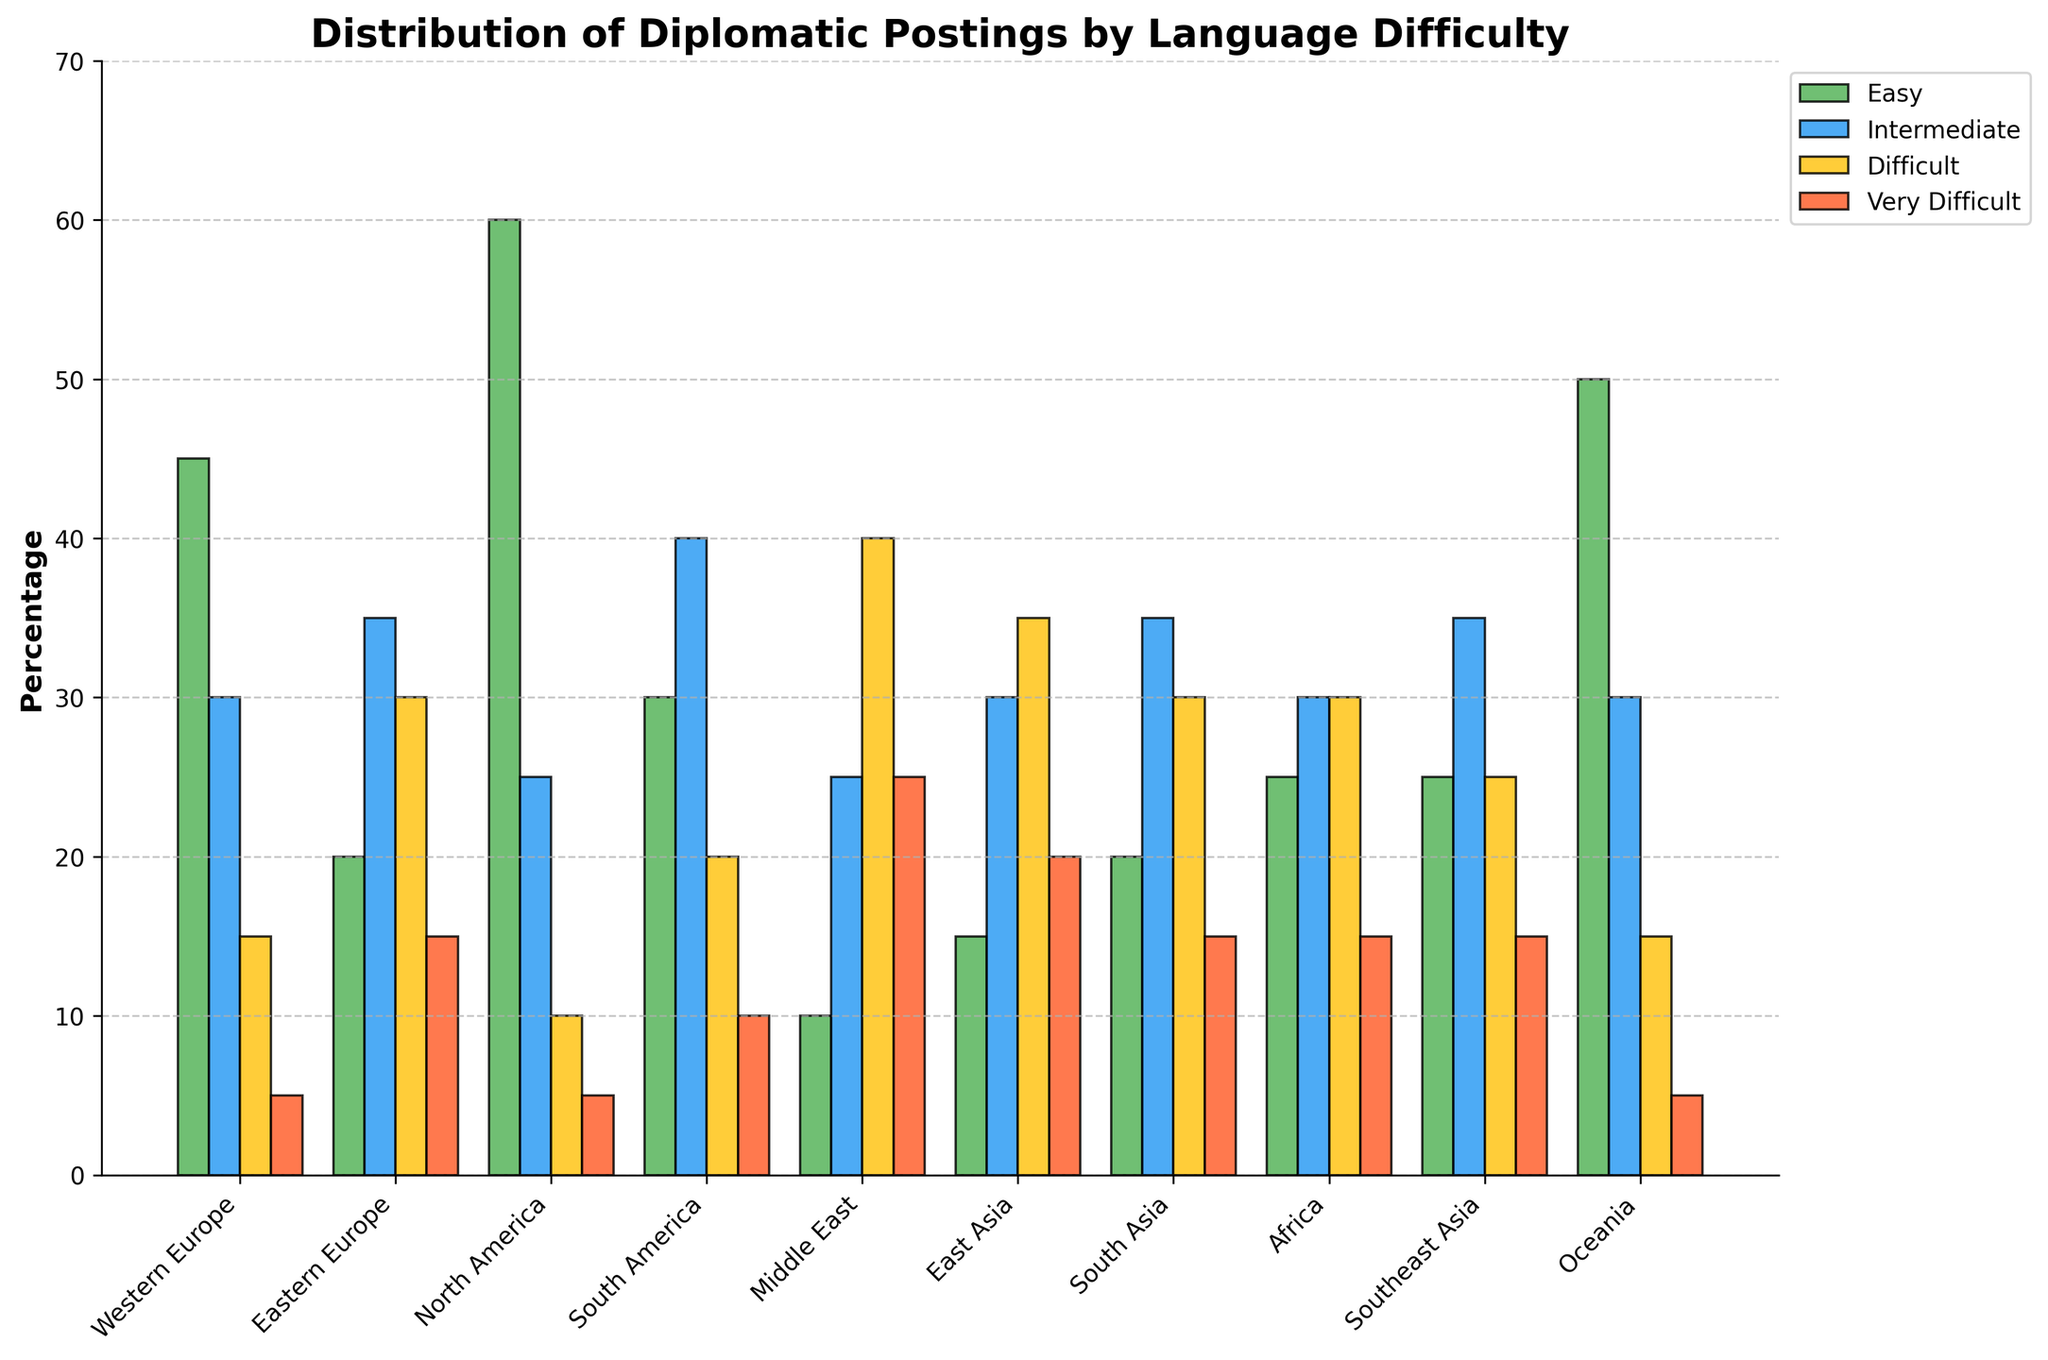Which region has the highest percentage of postings for 'Very Difficult' languages? The highest bar in the 'Very Difficult' category is compared across regions. The Middle East shows the highest bar in 'Very Difficult' languages.
Answer: Middle East In Western Europe, how does the percentage of 'Easy' postings compare to 'Intermediate' postings? In Western Europe, the 'Easy' bar is taller than the 'Intermediate' bar. 'Easy' has 45 postings and 'Intermediate' has 30.
Answer: 'Easy' is higher Which region has the smallest difference between 'Difficult' and 'Intermediate' postings? Calculate the difference between 'Difficult' and 'Intermediate' postings for each region. Africa has the smallest difference with both categories having 30 postings.
Answer: Africa How many disciplines in total have more than 30% postings for 'Difficult' languages? Count the number of bars for the 'Difficult' category that exceed the 30% mark. Middle East, East Asia, and South Asia meet this condition.
Answer: 3 Compare the total postings of 'Easy' languages in North America and Oceania, and determine the region with more postings. Add the 'Easy' postings for North America (60) and Oceania (50) and compare them. North America has more postings.
Answer: North America Is any region's 'Very Difficult' postings higher than its 'Intermediate' postings? Compare the height of the 'Very Difficult' and 'Intermediate' bars in each region. No region has higher 'Very Difficult' postings than 'Intermediate' postings.
Answer: No Which region has the highest total postings when combining 'Difficult' and 'Very Difficult' languages? Sum the 'Difficult' and 'Very Difficult' postings for each region and compare. Middle East has the highest combined total with (40 + 25) = 65 postings.
Answer: Middle East 